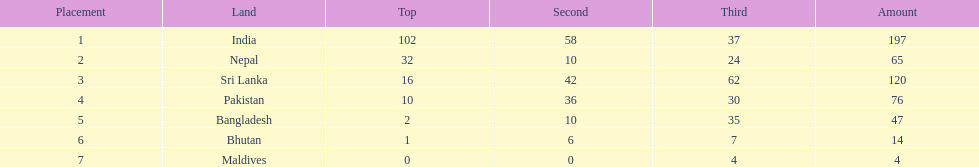What country has won no silver medals? Maldives. 